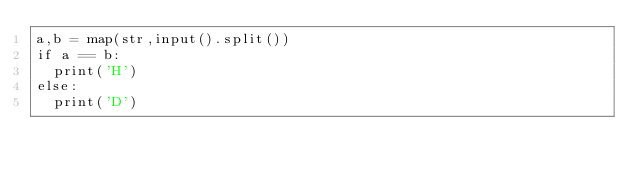<code> <loc_0><loc_0><loc_500><loc_500><_Python_>a,b = map(str,input().split())
if a == b:
  print('H')
else:
  print('D')</code> 